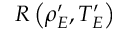Convert formula to latex. <formula><loc_0><loc_0><loc_500><loc_500>R \left ( \rho _ { E } ^ { \prime } , T _ { E } ^ { \prime } \right )</formula> 